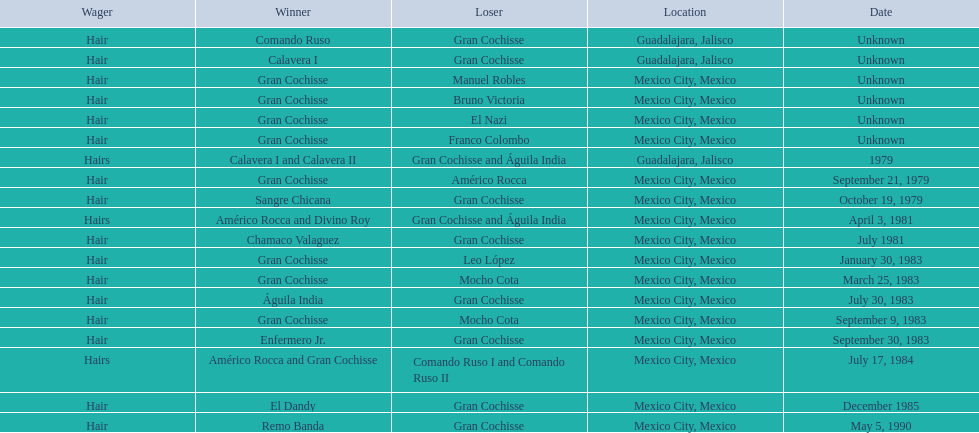How many times has gran cochisse been a winner? 9. 